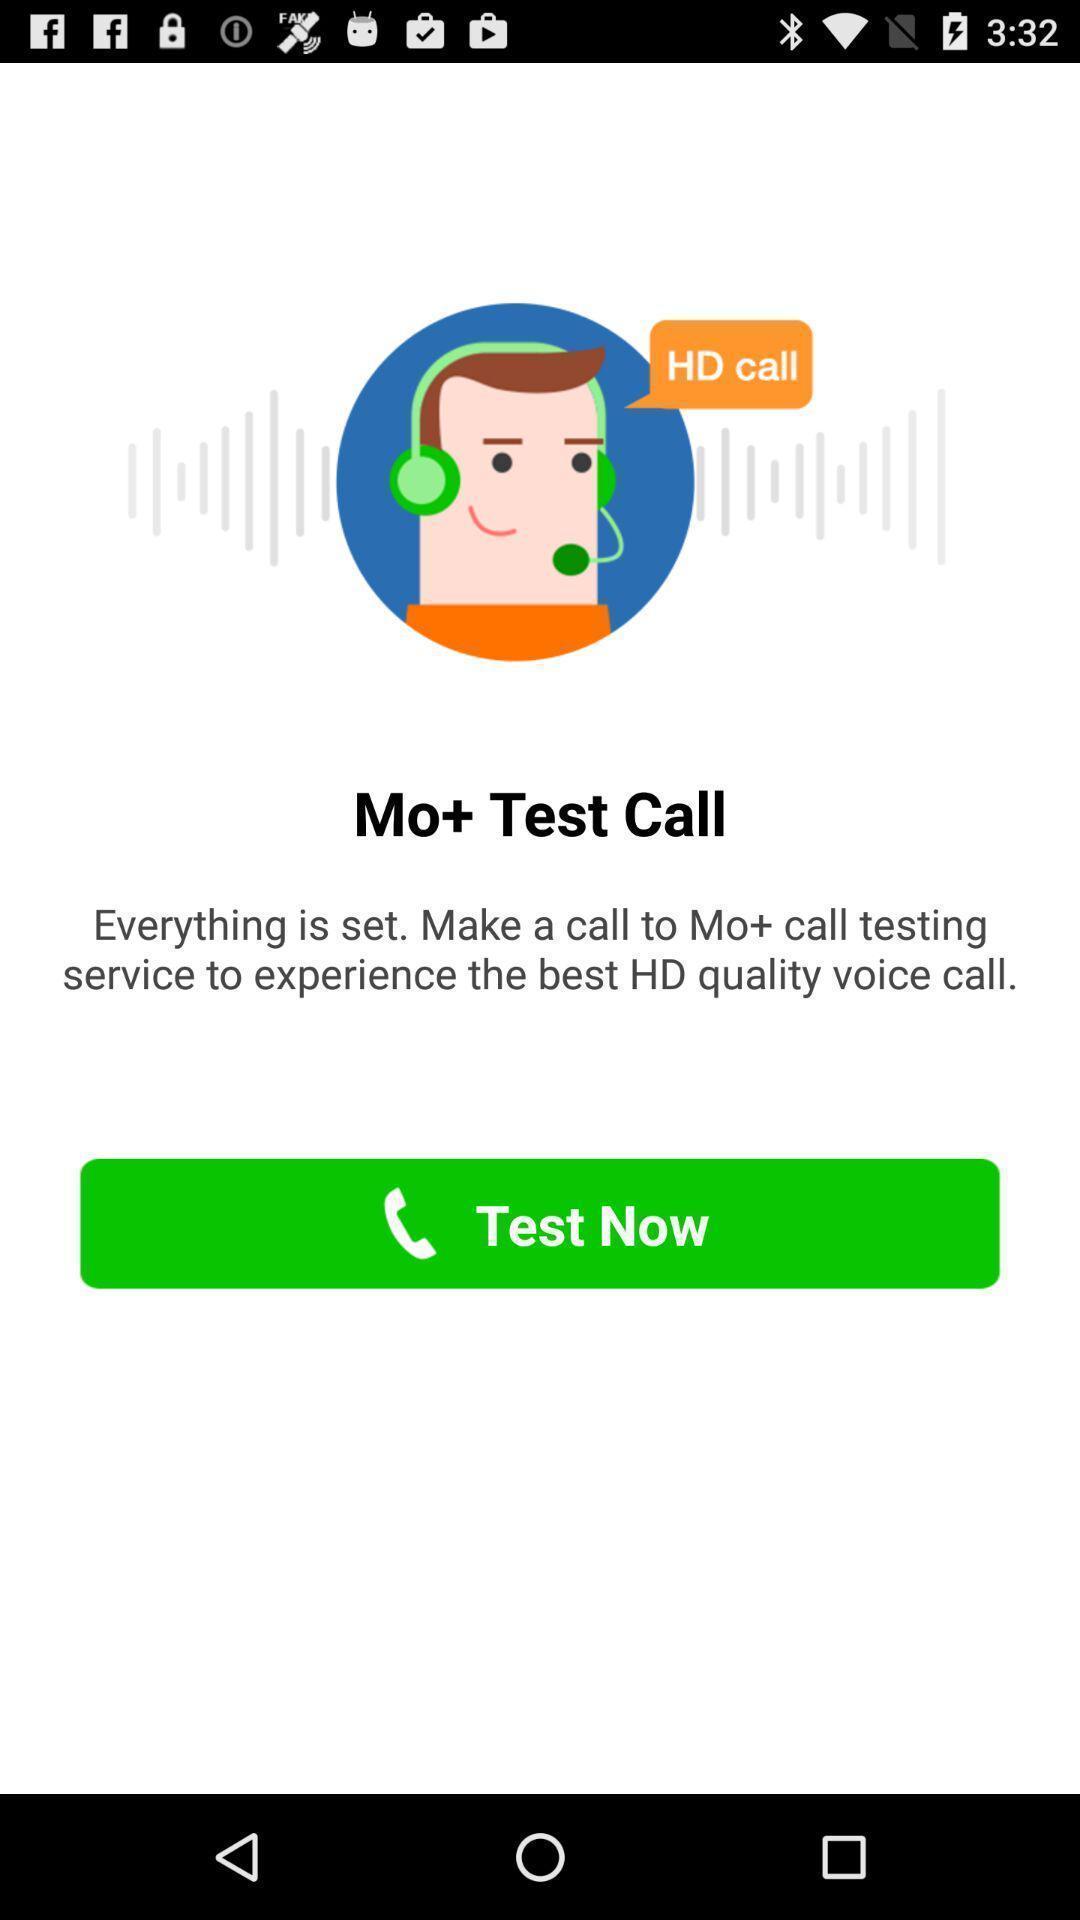Describe the key features of this screenshot. Test call page in a voice call app. 